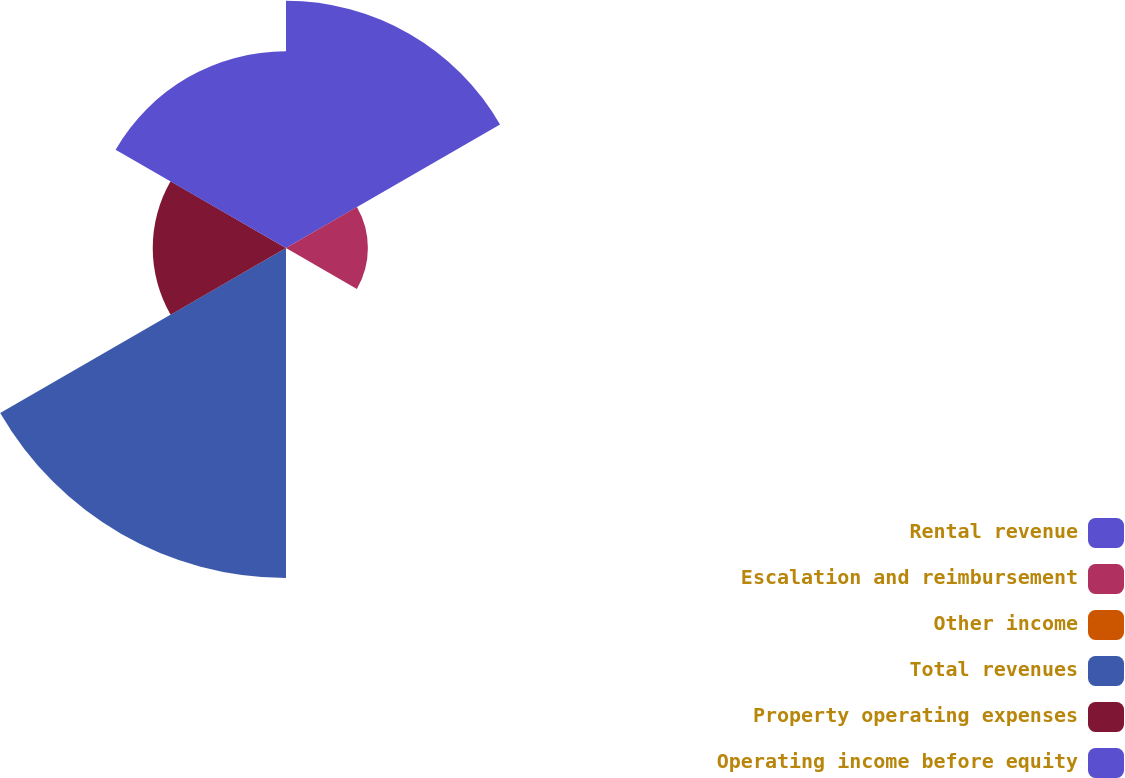Convert chart to OTSL. <chart><loc_0><loc_0><loc_500><loc_500><pie_chart><fcel>Rental revenue<fcel>Escalation and reimbursement<fcel>Other income<fcel>Total revenues<fcel>Property operating expenses<fcel>Operating income before equity<nl><fcel>24.96%<fcel>8.27%<fcel>0.1%<fcel>33.33%<fcel>13.46%<fcel>19.87%<nl></chart> 